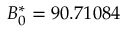<formula> <loc_0><loc_0><loc_500><loc_500>B _ { 0 } ^ { * } = 9 0 . 7 1 0 8 4</formula> 